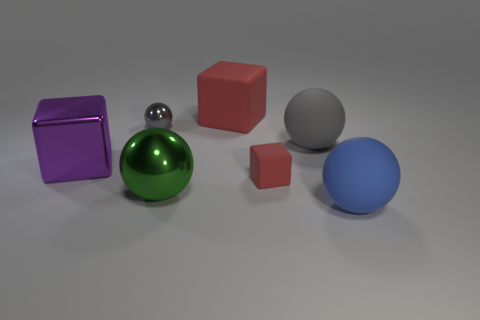Is the size of the gray object to the right of the green metallic sphere the same as the big red thing? The gray object to the right of the green metallic sphere is smaller in size compared to the larger red cube situated to its left. Visual analysis reveals a significant size disparity between the two objects. 